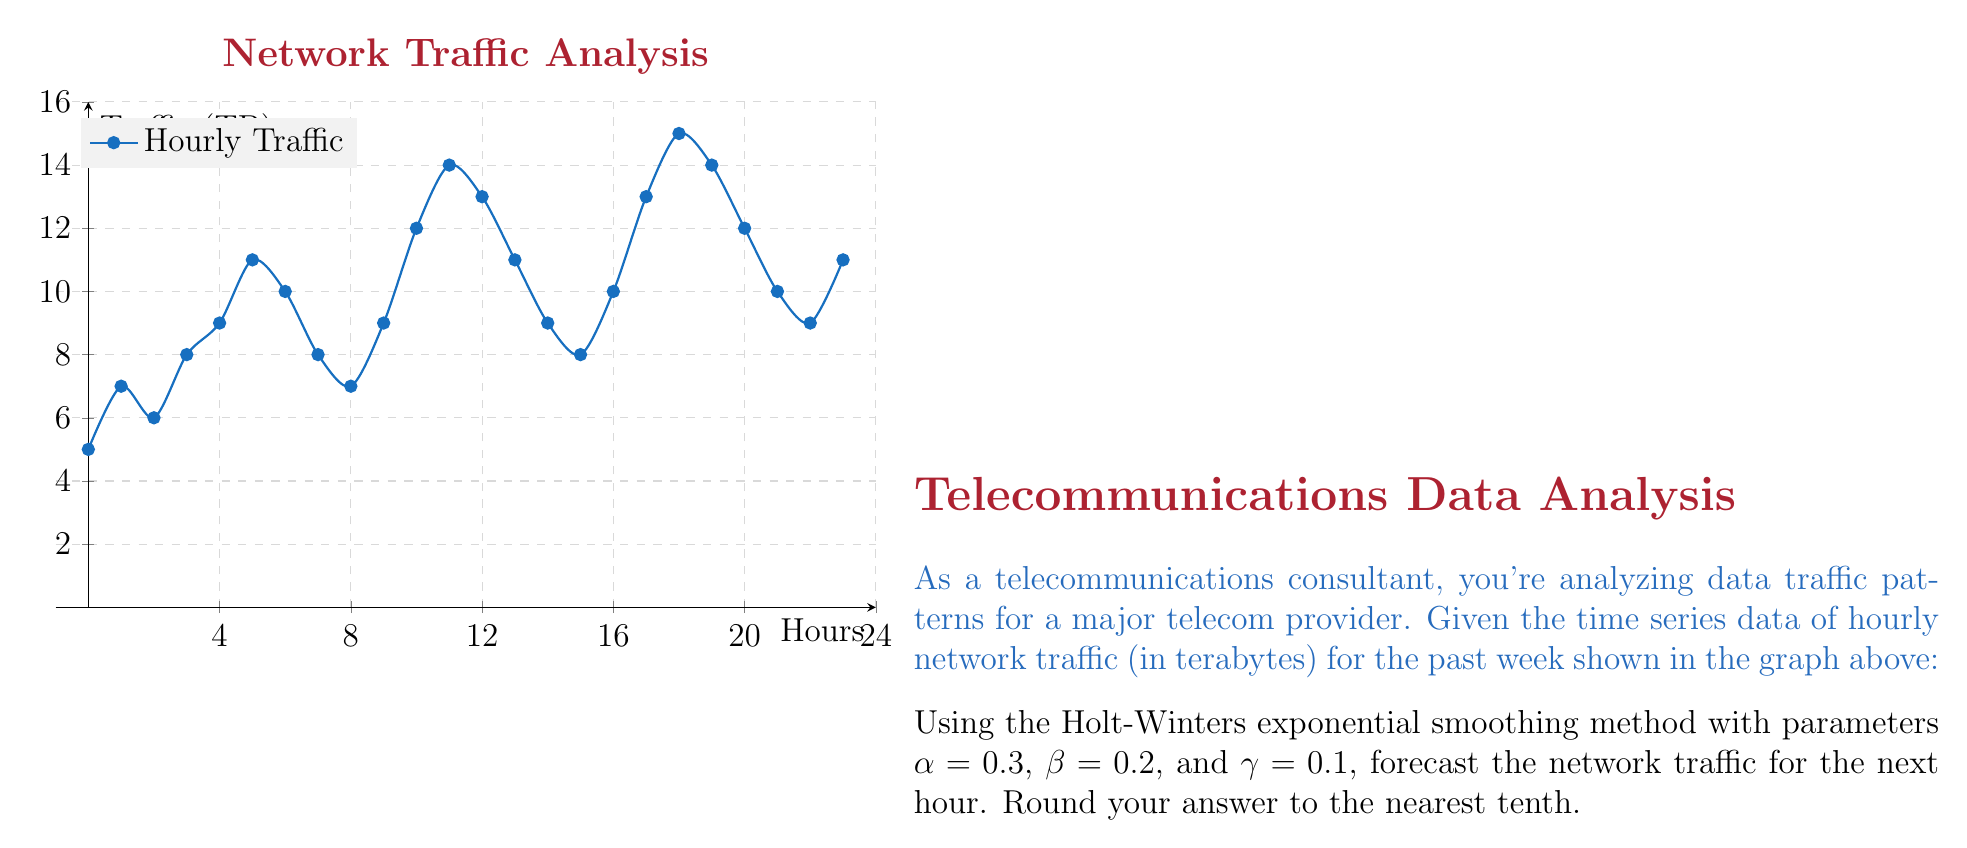Could you help me with this problem? To solve this problem using the Holt-Winters exponential smoothing method, we need to follow these steps:

1) The Holt-Winters method has three equations:
   
   Level: $L_t = \alpha(Y_t - S_{t-s}) + (1-\alpha)(L_{t-1} + T_{t-1})$
   Trend: $T_t = \beta(L_t - L_{t-1}) + (1-\beta)T_{t-1}$
   Seasonal: $S_t = \gamma(Y_t - L_t) + (1-\gamma)S_{t-s}$

   Where $s$ is the seasonal period (in this case, 24 hours).

2) The forecast is then given by: $F_{t+h} = L_t + hT_t + S_{t-s+h}$

3) We need to initialize $L_0$, $T_0$, and $S_i$ for $i=1$ to $s$. 
   Let's use the last 24 hours of data for initialization:
   
   $L_0 = \frac{1}{s}\sum_{i=1}^s Y_i = 10.25$
   
   $T_0 = \frac{1}{s}(\frac{Y_{s+1}-Y_1}{s} + \frac{Y_{s+2}-Y_2}{s} + ... + \frac{Y_{2s}-Y_s}{s}) = 0$
   
   $S_i = Y_i - L_0$ for $i=1$ to $s$

4) Now we can apply the Holt-Winters equations for the last data point:

   $L_{24} = 0.3(11 - (-0.25)) + (1-0.3)(10.25 + 0) = 10.7375$
   
   $T_{24} = 0.2(10.7375 - 10.25) + (1-0.2)0 = 0.0975$
   
   $S_{24} = 0.1(11 - 10.7375) + (1-0.1)(-0.25) = -0.2141$

5) Finally, we can forecast the next hour:

   $F_{25} = L_{24} + T_{24} + S_1$
   
   $F_{25} = 10.7375 + 0.0975 + (-5.25) = 5.585$

6) Rounding to the nearest tenth: 5.6 TB
Answer: 5.6 TB 